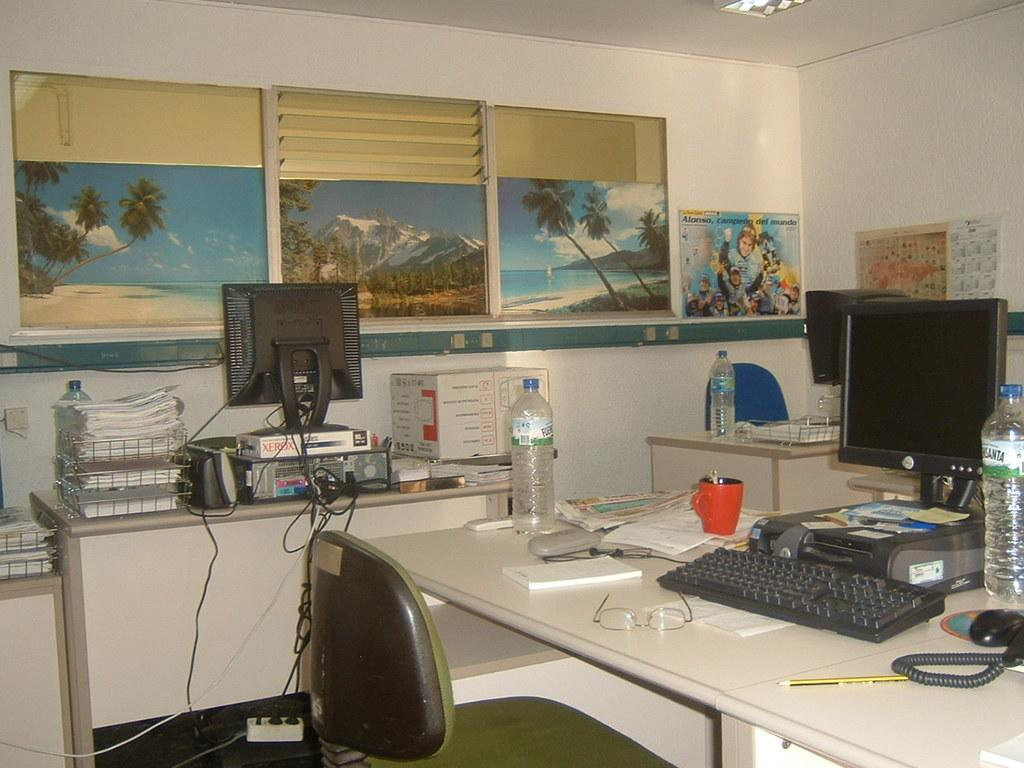<image>
Create a compact narrative representing the image presented. A computer monitor sits atop a white package marked Xerox. 